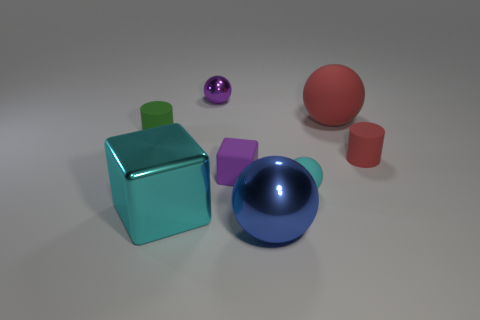There is another big object that is the same shape as the purple rubber thing; what is its material?
Offer a terse response. Metal. What number of things are matte spheres that are behind the tiny cyan rubber thing or small things that are in front of the tiny red cylinder?
Make the answer very short. 3. There is a green rubber object; is its shape the same as the small red matte thing behind the big cyan metal thing?
Make the answer very short. Yes. There is a tiny matte thing that is on the left side of the cyan shiny block that is in front of the red rubber object in front of the big matte sphere; what is its shape?
Your answer should be compact. Cylinder. What number of other things are made of the same material as the blue object?
Offer a terse response. 2. What number of objects are either tiny rubber objects on the right side of the small purple sphere or small green cylinders?
Provide a short and direct response. 4. There is a red matte object behind the tiny cylinder on the right side of the cyan rubber object; what is its shape?
Your answer should be compact. Sphere. Do the large object left of the small purple rubber object and the tiny purple rubber thing have the same shape?
Your answer should be compact. Yes. There is a cylinder that is to the left of the purple sphere; what color is it?
Ensure brevity in your answer.  Green. What number of blocks are big things or tiny red things?
Offer a very short reply. 1. 